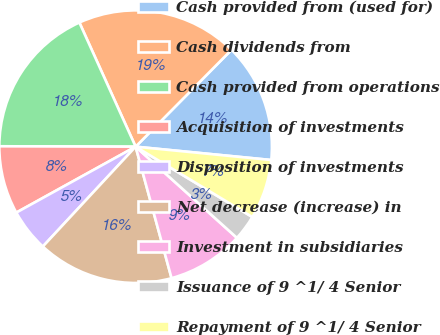<chart> <loc_0><loc_0><loc_500><loc_500><pie_chart><fcel>Cash provided from (used for)<fcel>Cash dividends from<fcel>Cash provided from operations<fcel>Acquisition of investments<fcel>Disposition of investments<fcel>Net decrease (increase) in<fcel>Investment in subsidiaries<fcel>Issuance of 9 ^1/ 4 Senior<fcel>Repayment of 9 ^1/ 4 Senior<nl><fcel>14.14%<fcel>19.19%<fcel>18.18%<fcel>8.08%<fcel>5.05%<fcel>16.16%<fcel>9.09%<fcel>3.03%<fcel>7.07%<nl></chart> 